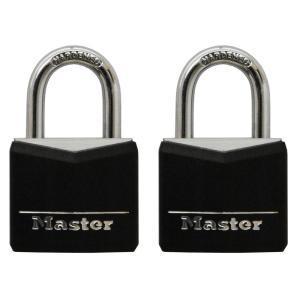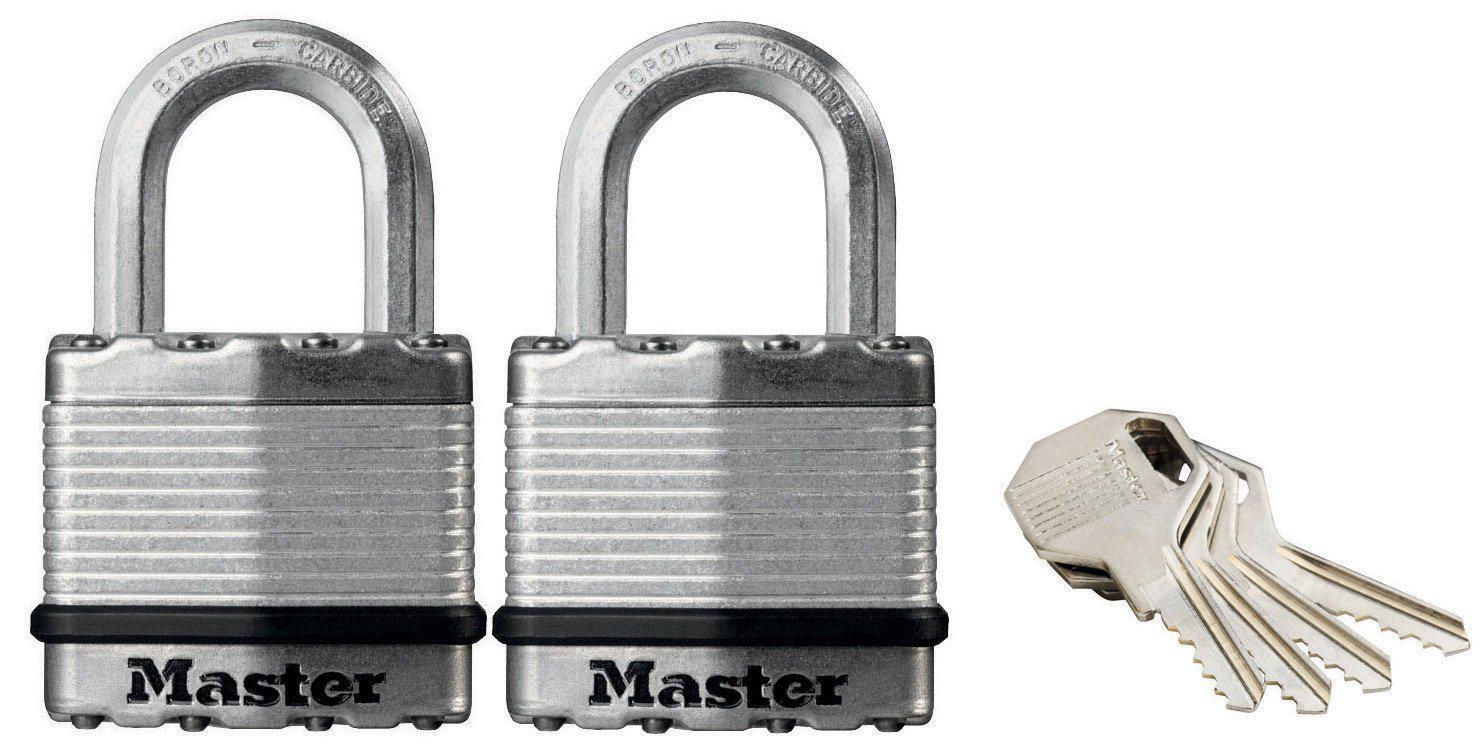The first image is the image on the left, the second image is the image on the right. Assess this claim about the two images: "Multiple keys are next to a pair of the same type locks in one image.". Correct or not? Answer yes or no. Yes. The first image is the image on the left, the second image is the image on the right. Assess this claim about the two images: "There are four padlocks, all of which are closed.". Correct or not? Answer yes or no. Yes. 